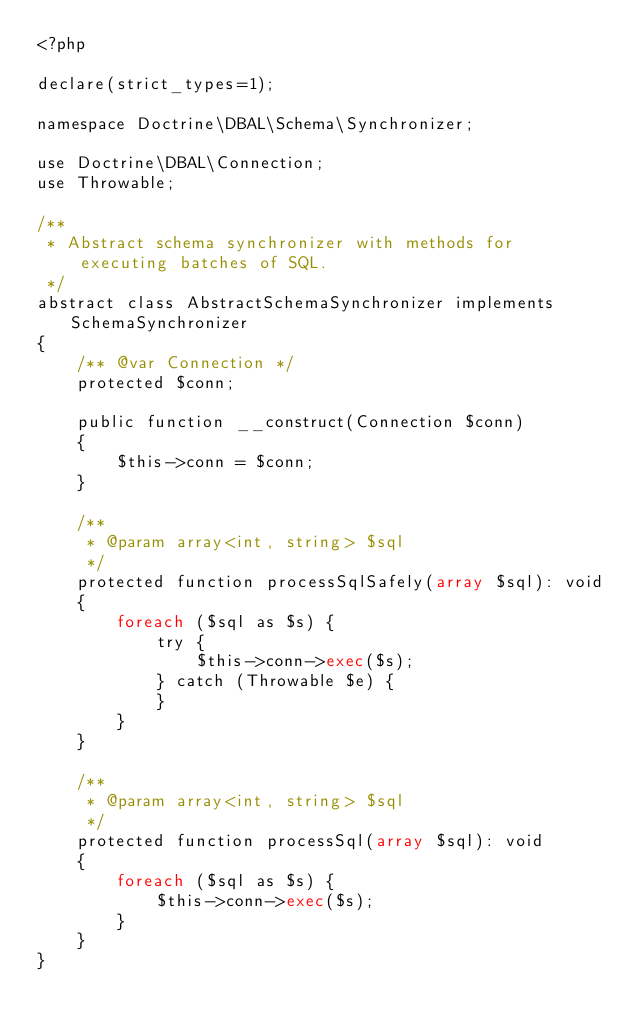Convert code to text. <code><loc_0><loc_0><loc_500><loc_500><_PHP_><?php

declare(strict_types=1);

namespace Doctrine\DBAL\Schema\Synchronizer;

use Doctrine\DBAL\Connection;
use Throwable;

/**
 * Abstract schema synchronizer with methods for executing batches of SQL.
 */
abstract class AbstractSchemaSynchronizer implements SchemaSynchronizer
{
    /** @var Connection */
    protected $conn;

    public function __construct(Connection $conn)
    {
        $this->conn = $conn;
    }

    /**
     * @param array<int, string> $sql
     */
    protected function processSqlSafely(array $sql): void
    {
        foreach ($sql as $s) {
            try {
                $this->conn->exec($s);
            } catch (Throwable $e) {
            }
        }
    }

    /**
     * @param array<int, string> $sql
     */
    protected function processSql(array $sql): void
    {
        foreach ($sql as $s) {
            $this->conn->exec($s);
        }
    }
}
</code> 